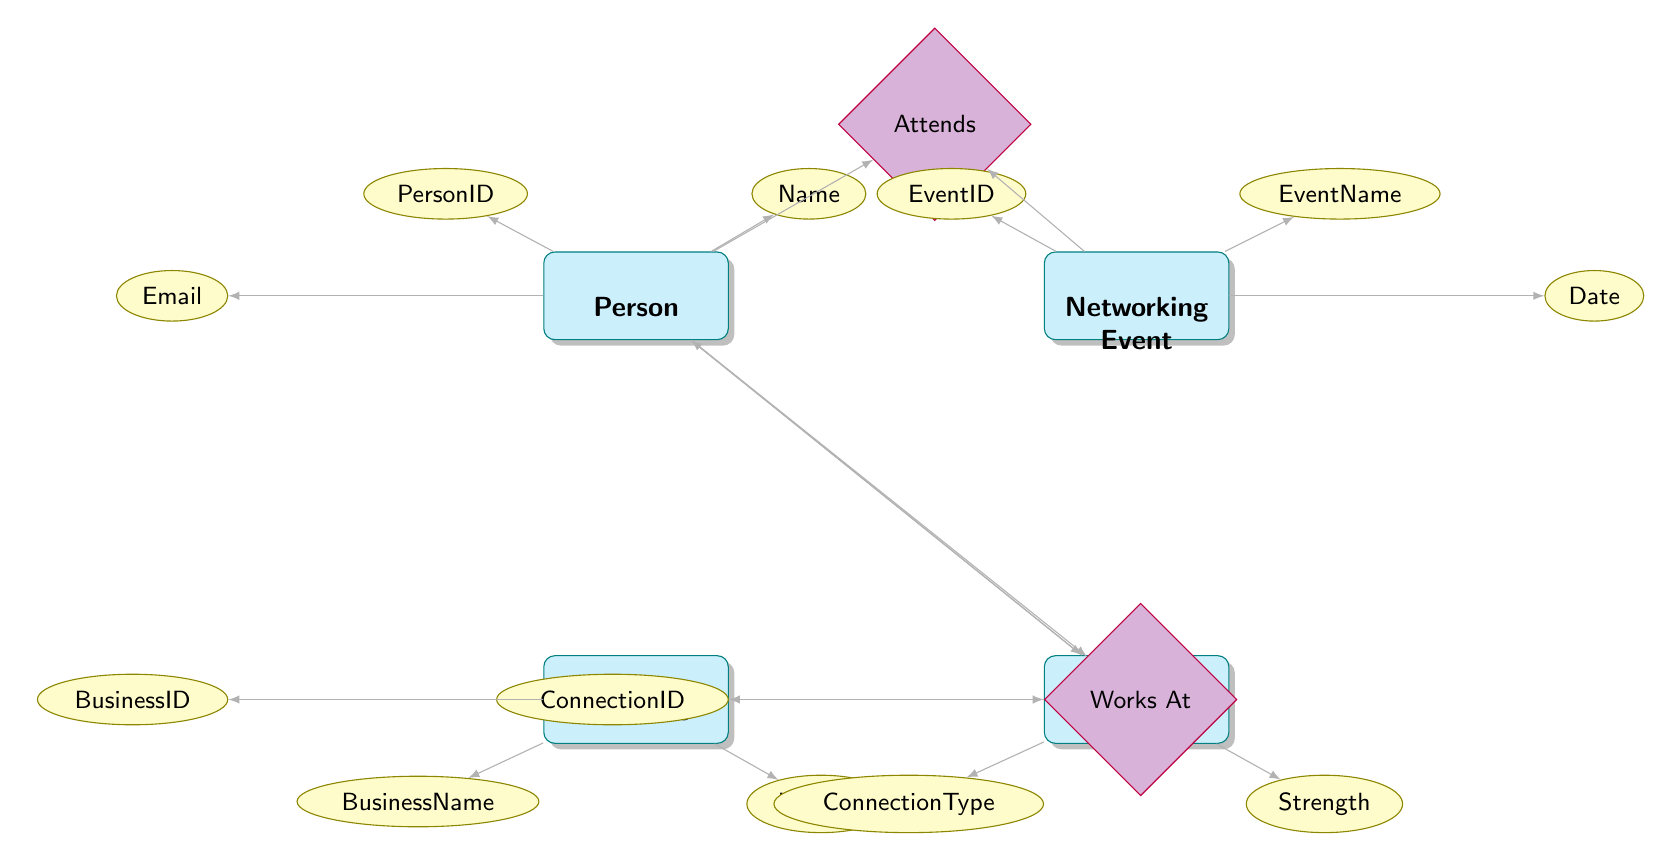What is the primary entity in the diagram? The diagram highlights "Person" as the central entity among others such as "NetworkingEvent," "Business," and "Connection." It has connecting relationships, indicating its importance.
Answer: Person How many attributes does the 'Business' entity have? The 'Business' entity consists of three attributes: BusinessID, BusinessName, and Industry. By evaluating the listed components under the Business node, we find these three attributes.
Answer: 3 What relationship connects 'Person' and 'NetworkingEvent’? The relationship "Attends" directly links the entities 'Person' and 'NetworkingEvent' within the diagram, as it is associated with the connections between the two.
Answer: Attends What is the strength of a connection? The attribute "Strength" describes the capacity or depth of a connection and is found associated with the 'Connection' entity in the diagram.
Answer: Strength Which entity has an attribute 'Email'? The 'Person' entity has the 'Email' attribute listed among its attributes, indicating that this data is specific to individuals in the diagram.
Answer: Person How many relationships are illustrated in the diagram? There are two main relationships depicted in the diagram: "Attends" and "Works At," which connect various entities and reveal their interactions.
Answer: 2 What kind of event does 'Attends' relationship signify? The "Attends" relationship signifies participation in a 'NetworkingEvent' by a 'Person,' indicating person-to-event interaction within the business networking context.
Answer: Networking Event What connection type might be represented in the diagram? The 'ConnectionType' attribute signifies the nature of the relationship shared between two persons connected in the 'Connection' entity, representing various forms of interpersonal links.
Answer: ConnectionType 